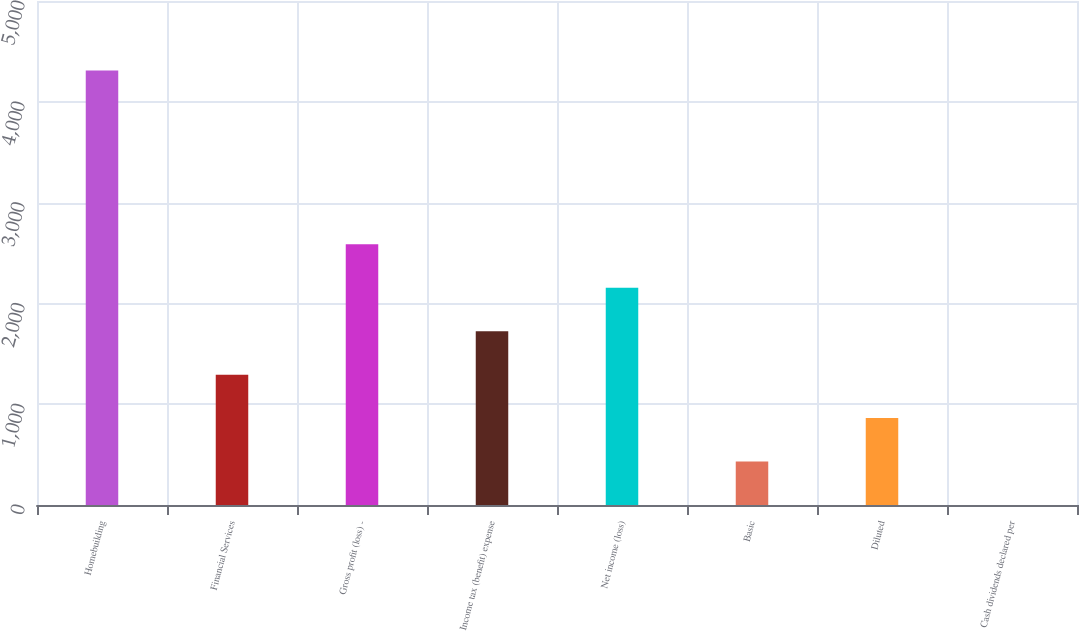Convert chart to OTSL. <chart><loc_0><loc_0><loc_500><loc_500><bar_chart><fcel>Homebuilding<fcel>Financial Services<fcel>Gross profit (loss) -<fcel>Income tax (benefit) expense<fcel>Net income (loss)<fcel>Basic<fcel>Diluted<fcel>Cash dividends declared per<nl><fcel>4309.7<fcel>1293.03<fcel>2585.9<fcel>1723.99<fcel>2154.95<fcel>431.11<fcel>862.07<fcel>0.15<nl></chart> 